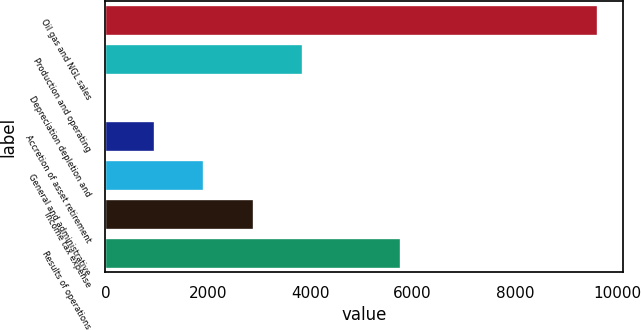<chart> <loc_0><loc_0><loc_500><loc_500><bar_chart><fcel>Oil gas and NGL sales<fcel>Production and operating<fcel>Depreciation depletion and<fcel>Accretion of asset retirement<fcel>General and administrative<fcel>Income tax expense<fcel>Results of operations<nl><fcel>9626<fcel>3857.51<fcel>11.85<fcel>973.26<fcel>1934.67<fcel>2896.09<fcel>5780.35<nl></chart> 